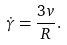<formula> <loc_0><loc_0><loc_500><loc_500>\dot { \gamma } = \frac { 3 v } { R } .</formula> 